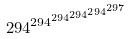<formula> <loc_0><loc_0><loc_500><loc_500>2 9 4 ^ { 2 9 4 ^ { 2 9 4 ^ { 2 9 4 ^ { 2 9 4 ^ { 2 9 7 } } } } }</formula> 